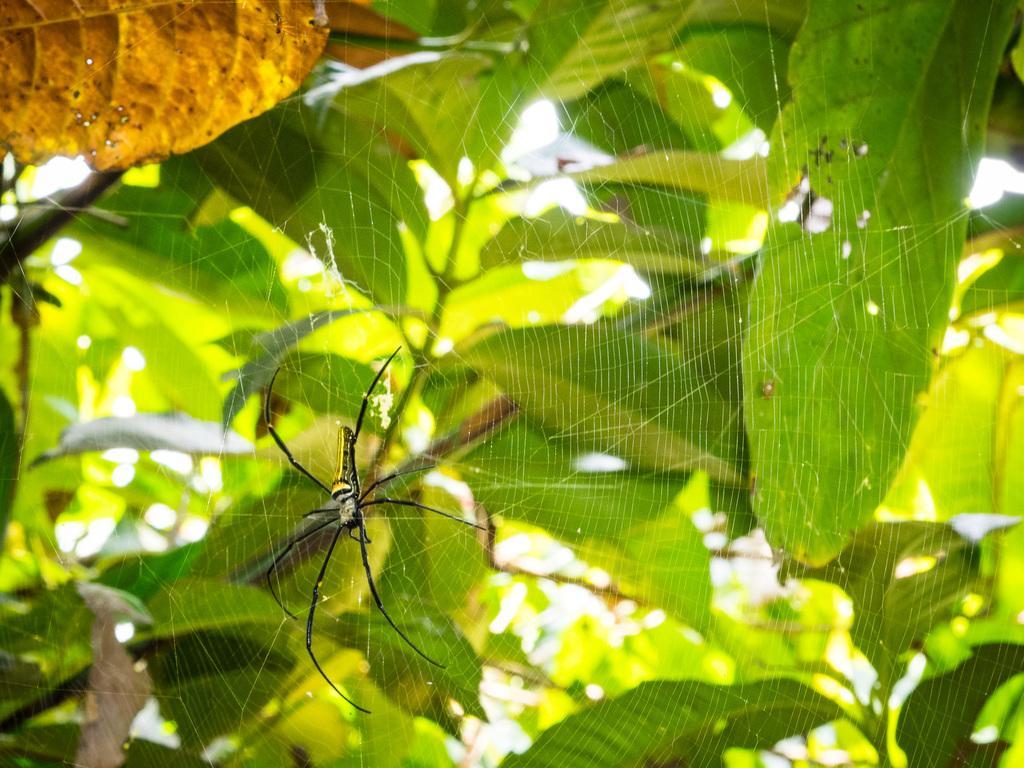How would you summarize this image in a sentence or two? In this image we can see a tree. There is a spider and spider web on the tree in the image. 